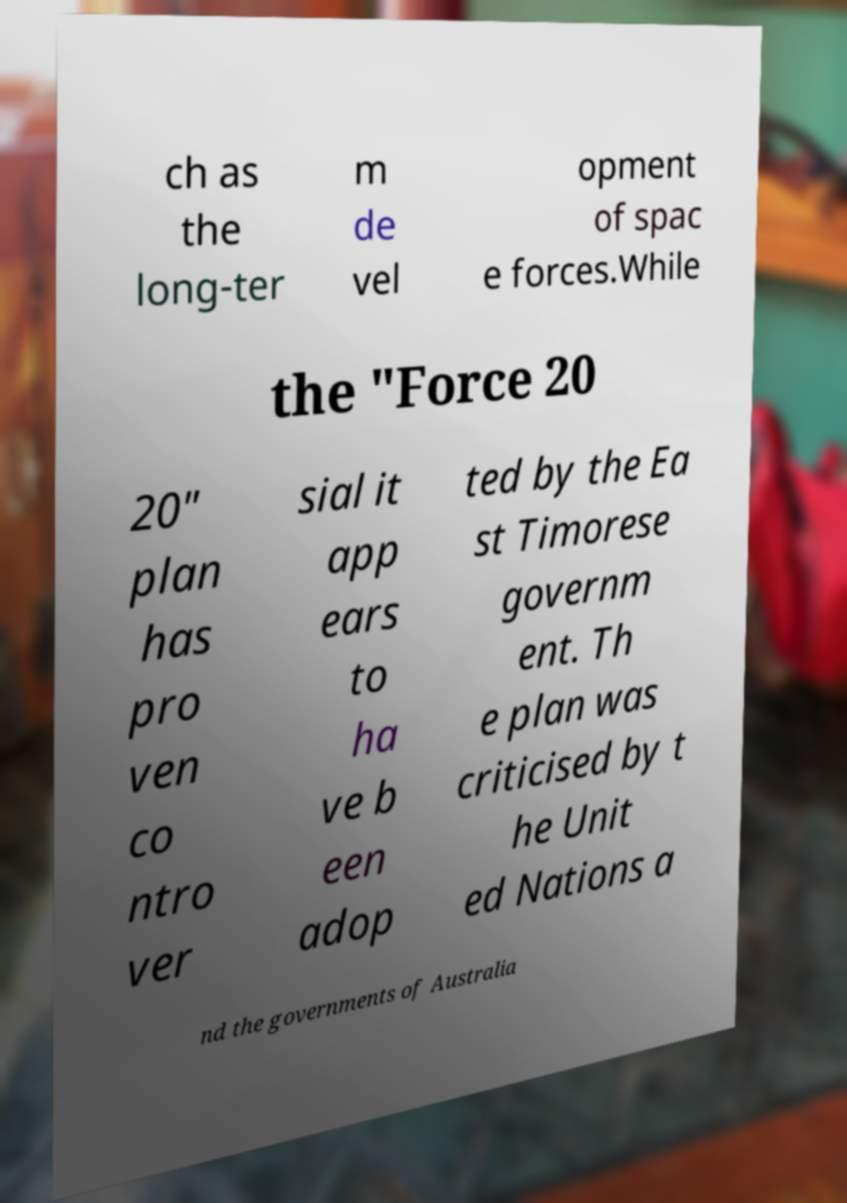Could you assist in decoding the text presented in this image and type it out clearly? ch as the long-ter m de vel opment of spac e forces.While the "Force 20 20" plan has pro ven co ntro ver sial it app ears to ha ve b een adop ted by the Ea st Timorese governm ent. Th e plan was criticised by t he Unit ed Nations a nd the governments of Australia 